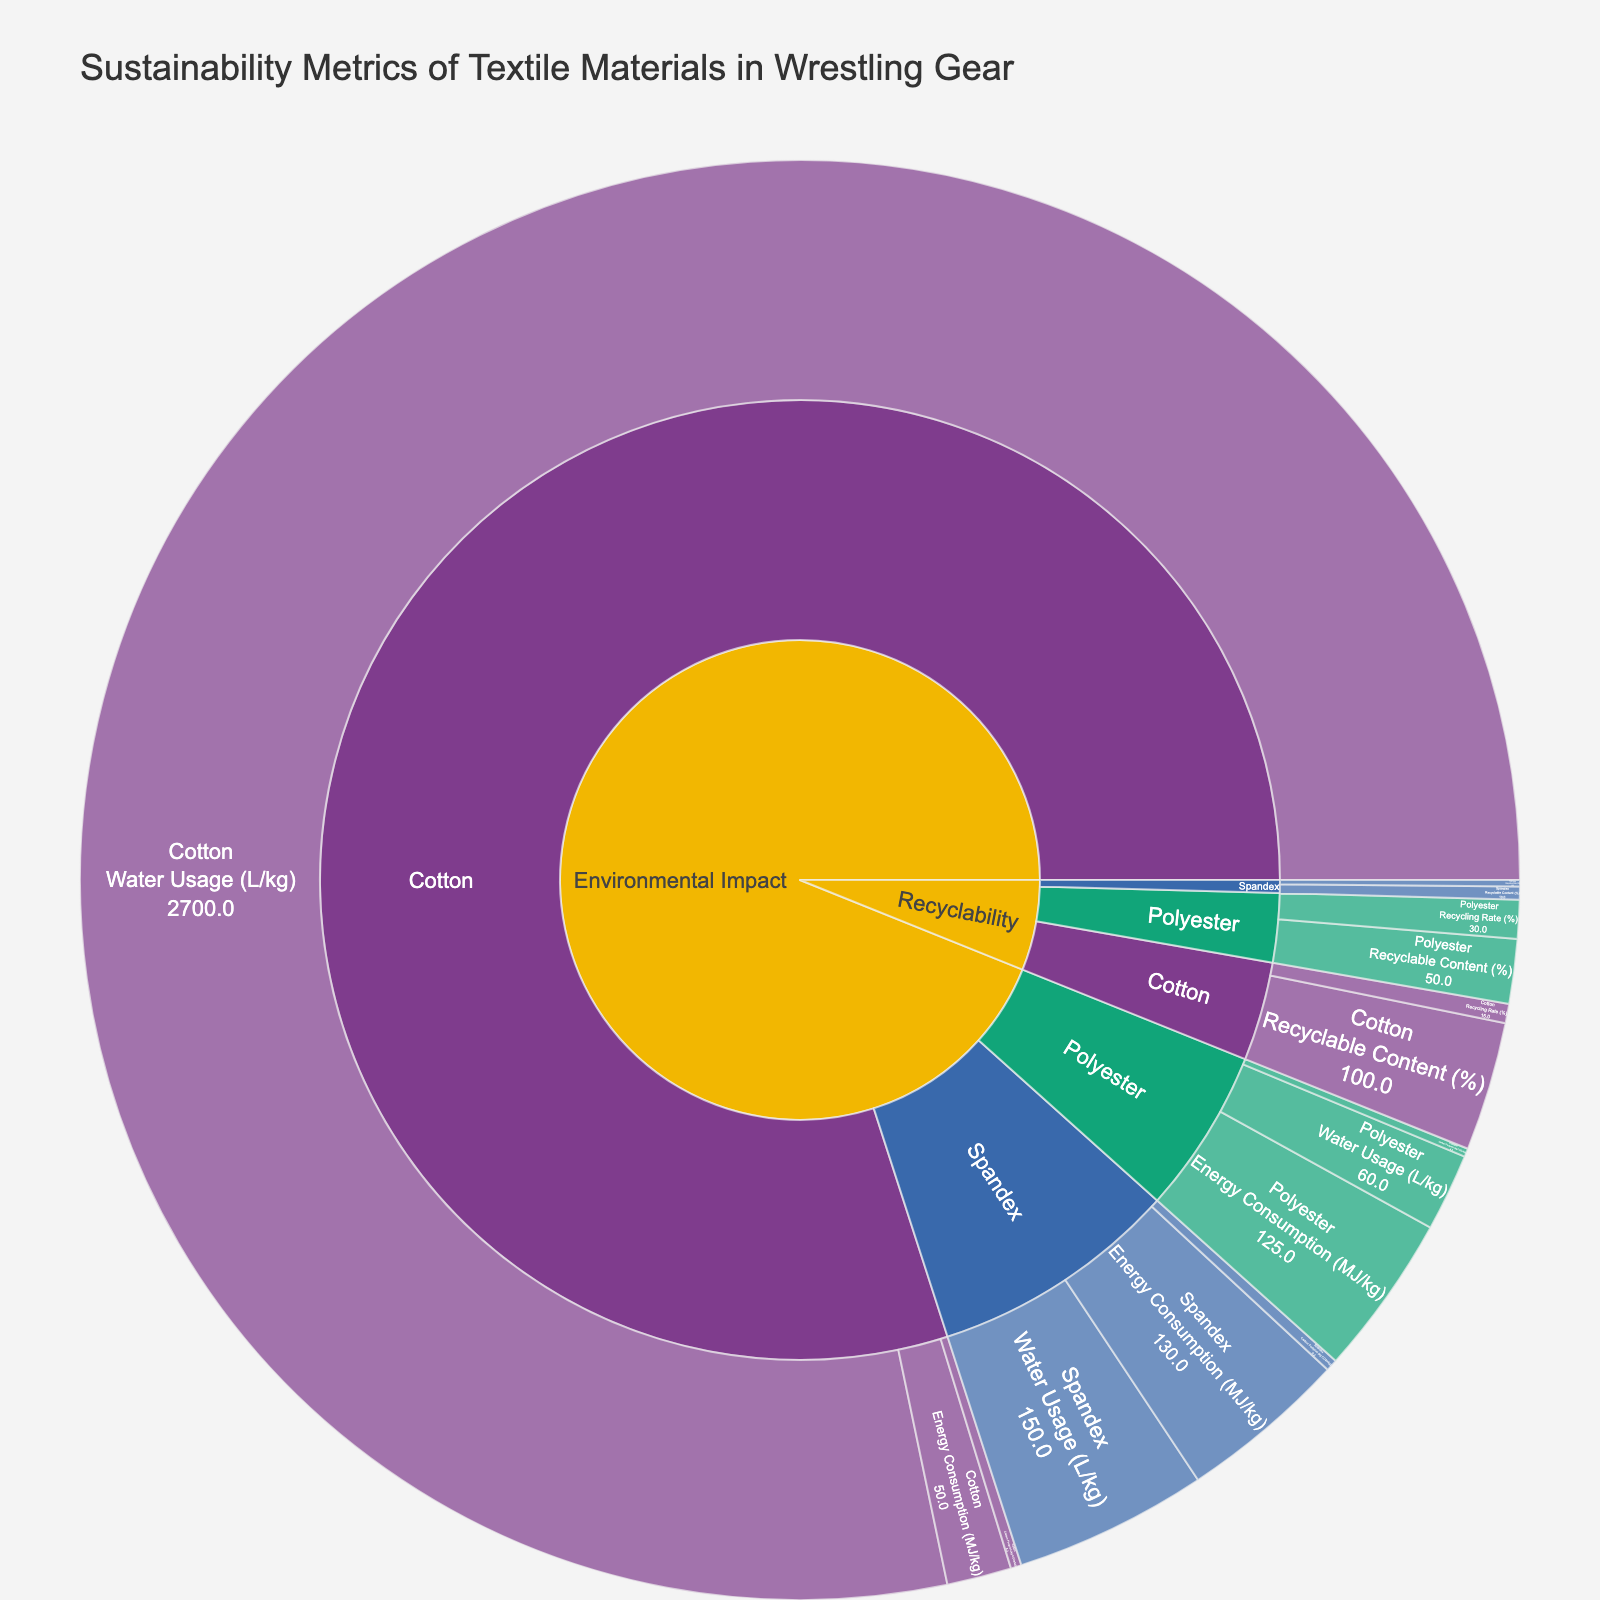What's the title of the plot? The title of the plot is usually prominently displayed at the top of the figure. It provides a concise description of what the plot represents. In this case, the title is provided in the code as 'Sustainability Metrics of Textile Materials in Wrestling Gear'.
Answer: Sustainability Metrics of Textile Materials in Wrestling Gear Which material has the highest carbon footprint per kilogram? To answer this, we look at the 'Environmental Impact' category under 'Carbon Footprint (kg CO2e/kg)' and compare the values for Polyester, Cotton, and Spandex. Polyester: 6.5 kg CO2e/kg, Cotton: 8.3 kg CO2e/kg, Spandex: 9.2 kg CO2e/kg, so Spandex has the highest.
Answer: Spandex What is the water usage for cotton per kilogram? We need to locate the 'Environmental Impact' category under 'Water Usage (L/kg)' and find the corresponding value for Cotton.
Answer: 2700 L/kg Compare the energy consumption per kilogram between Polyester and Spandex. Which one is higher? Comparing the values under 'Environmental Impact' for 'Energy Consumption (MJ/kg)', Polyester: 125 MJ/kg, Spandex: 130 MJ/kg. Spandex has a higher energy consumption.
Answer: Spandex What is the recycling rate for Polyester? To find this, we look under the 'Recyclability' category and check the values under 'Recycling Rate (%)' for Polyester.
Answer: 30% Which material has the lowest recycling rate? Under the 'Recyclability' category, we find the 'Recycling Rate (%)' values for Polyester, Cotton, and Spandex and compare them: Polyester: 30%, Cotton: 15%, Spandex: 5%. Spandex has the lowest recycling rate.
Answer: Spandex How does the recyclable content of Cotton compare to Polyester? Under 'Recyclability', compare 'Recyclable Content (%)': Polyester: 50%, Cotton: 100%. Cotton has a higher recyclable content than Polyester.
Answer: Cotton has a higher recyclable content Calculate the total carbon footprint for producing 1 kg each of Polyester, Cotton, and Spandex. Add the carbon footprints: Polyester (6.5 kg CO2e) + Cotton (8.3 kg CO2e) + Spandex (9.2 kg CO2e) = 24 kg CO2e.
Answer: 24 kg CO2e Which material uses the least water per kilogram? Under the 'Environmental Impact' category, we compare 'Water Usage (L/kg)' for Polyester, Cotton, and Spandex: Polyester: 60 L/kg, Cotton: 2700 L/kg, Spandex: 150 L/kg. Polyester uses the least.
Answer: Polyester What percentage of Spandex material is recyclable? Look under the 'Recyclability' category for 'Recyclable Content (%)' for Spandex.
Answer: 10% 